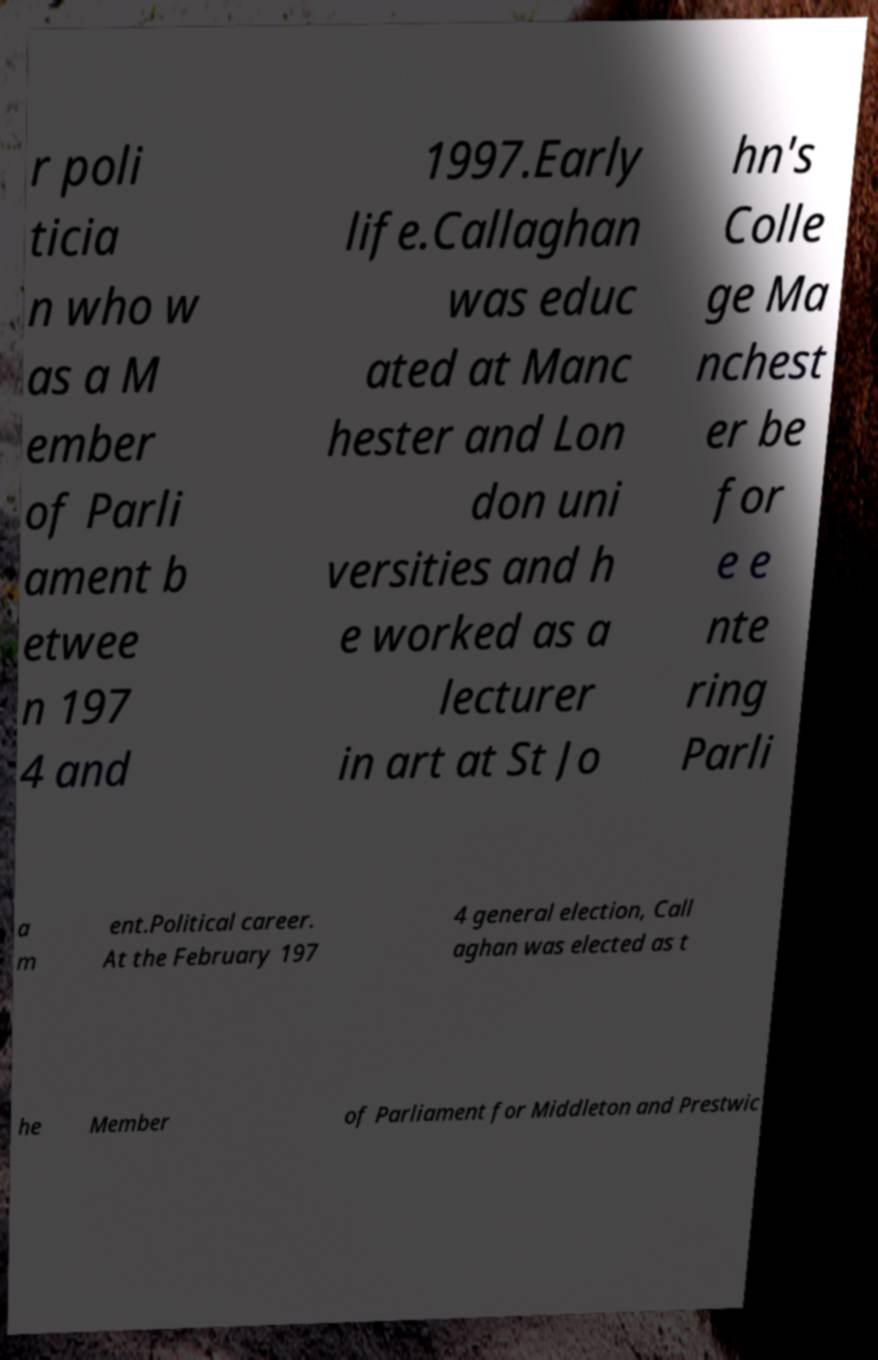Could you assist in decoding the text presented in this image and type it out clearly? r poli ticia n who w as a M ember of Parli ament b etwee n 197 4 and 1997.Early life.Callaghan was educ ated at Manc hester and Lon don uni versities and h e worked as a lecturer in art at St Jo hn's Colle ge Ma nchest er be for e e nte ring Parli a m ent.Political career. At the February 197 4 general election, Call aghan was elected as t he Member of Parliament for Middleton and Prestwic 